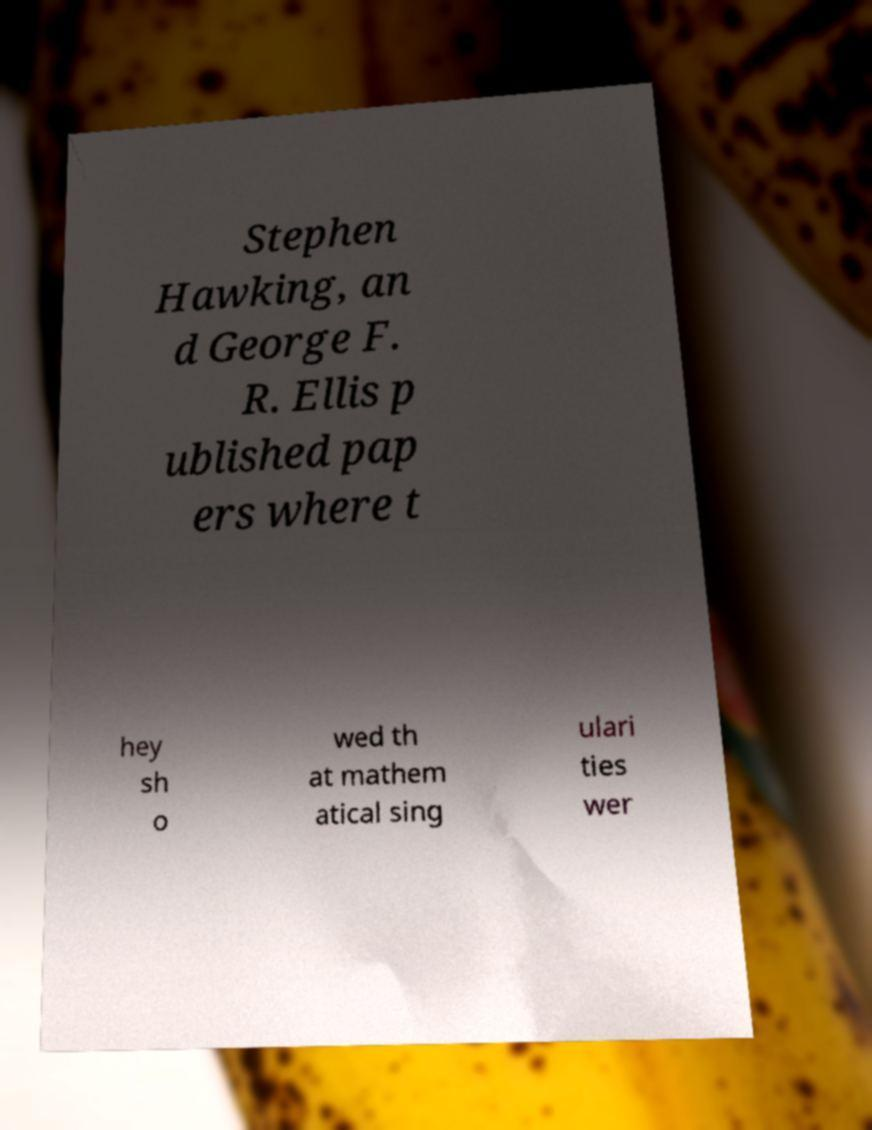What messages or text are displayed in this image? I need them in a readable, typed format. Stephen Hawking, an d George F. R. Ellis p ublished pap ers where t hey sh o wed th at mathem atical sing ulari ties wer 